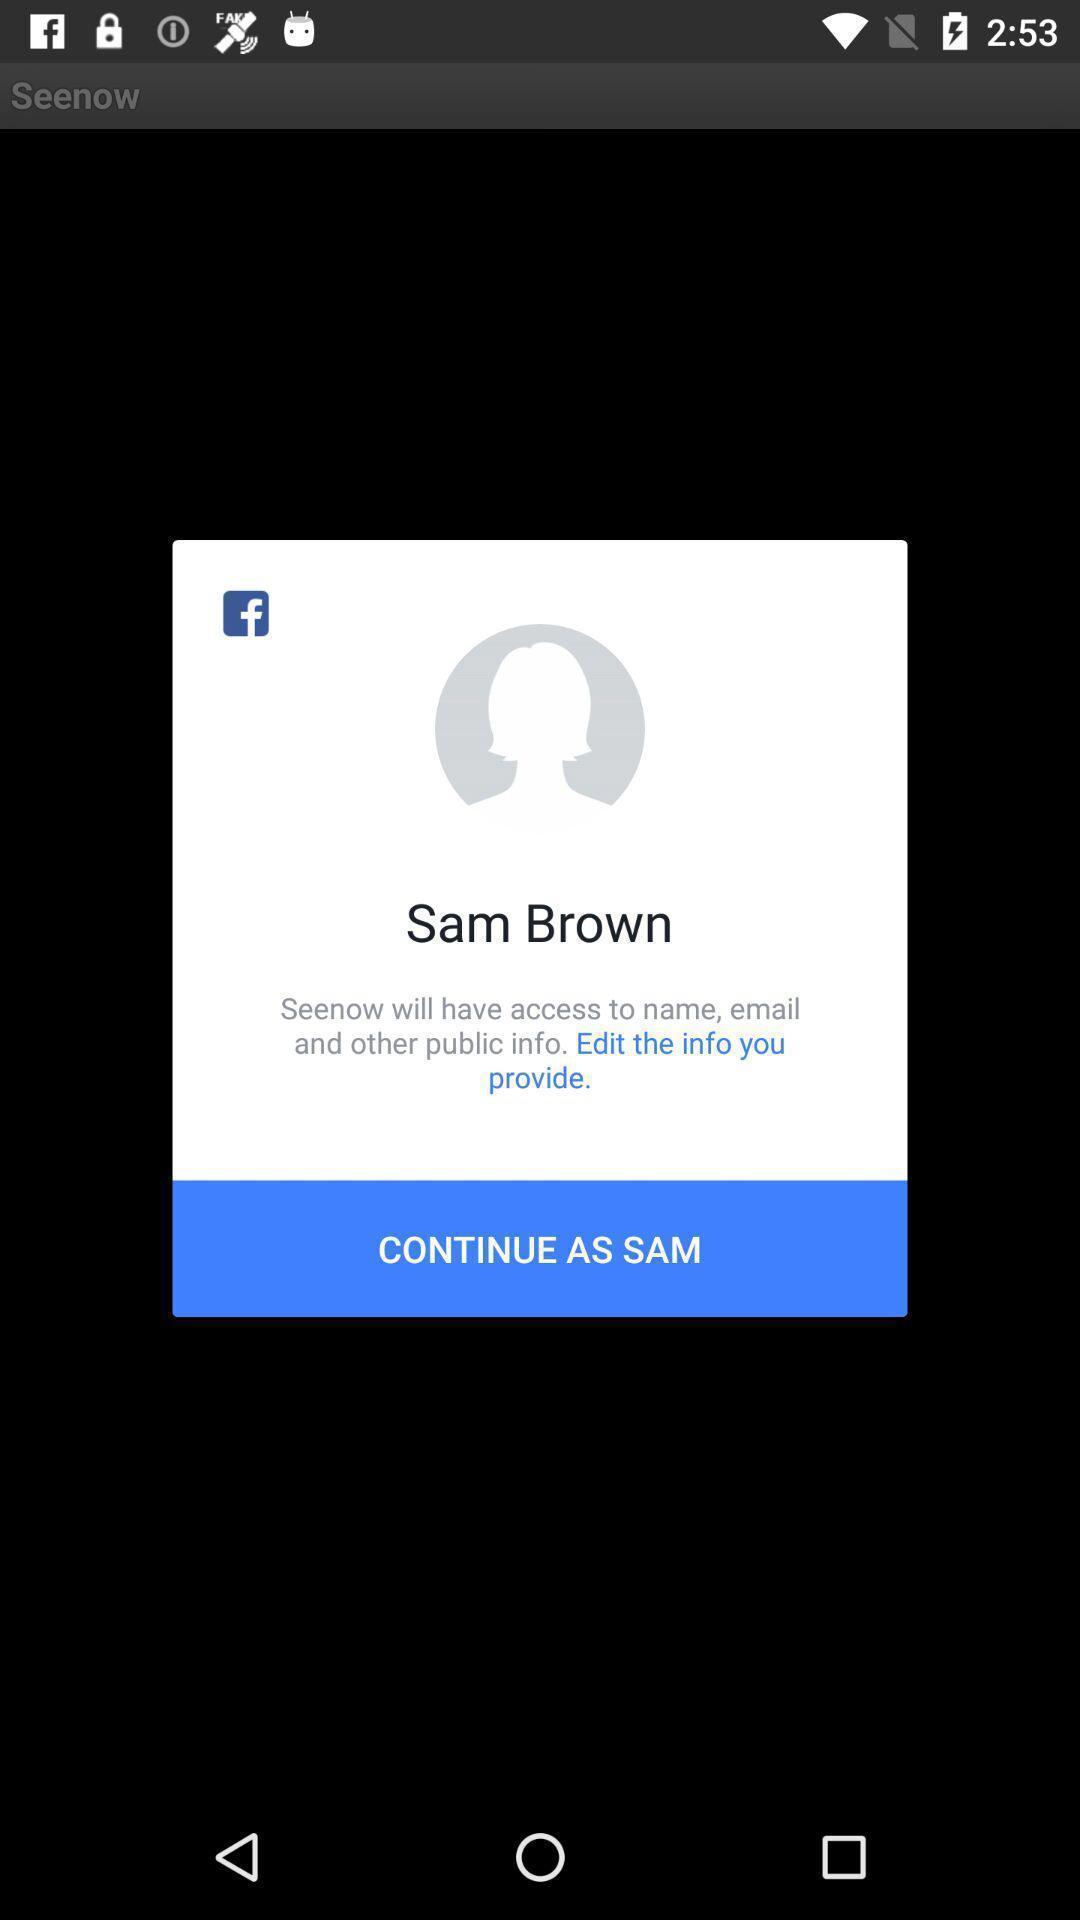Tell me what you see in this picture. Popup to continue in the application. 